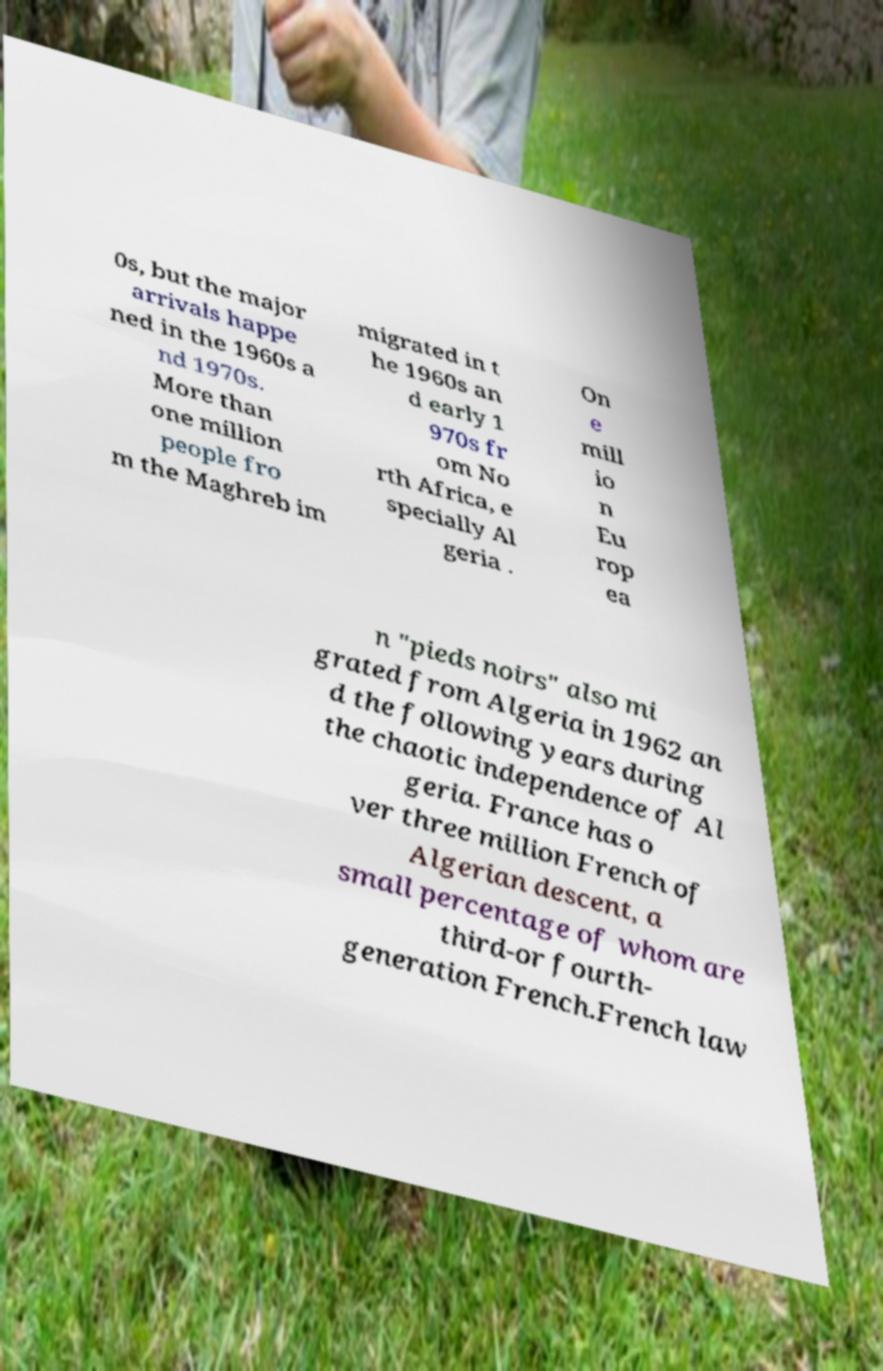Please identify and transcribe the text found in this image. 0s, but the major arrivals happe ned in the 1960s a nd 1970s. More than one million people fro m the Maghreb im migrated in t he 1960s an d early 1 970s fr om No rth Africa, e specially Al geria . On e mill io n Eu rop ea n "pieds noirs" also mi grated from Algeria in 1962 an d the following years during the chaotic independence of Al geria. France has o ver three million French of Algerian descent, a small percentage of whom are third-or fourth- generation French.French law 